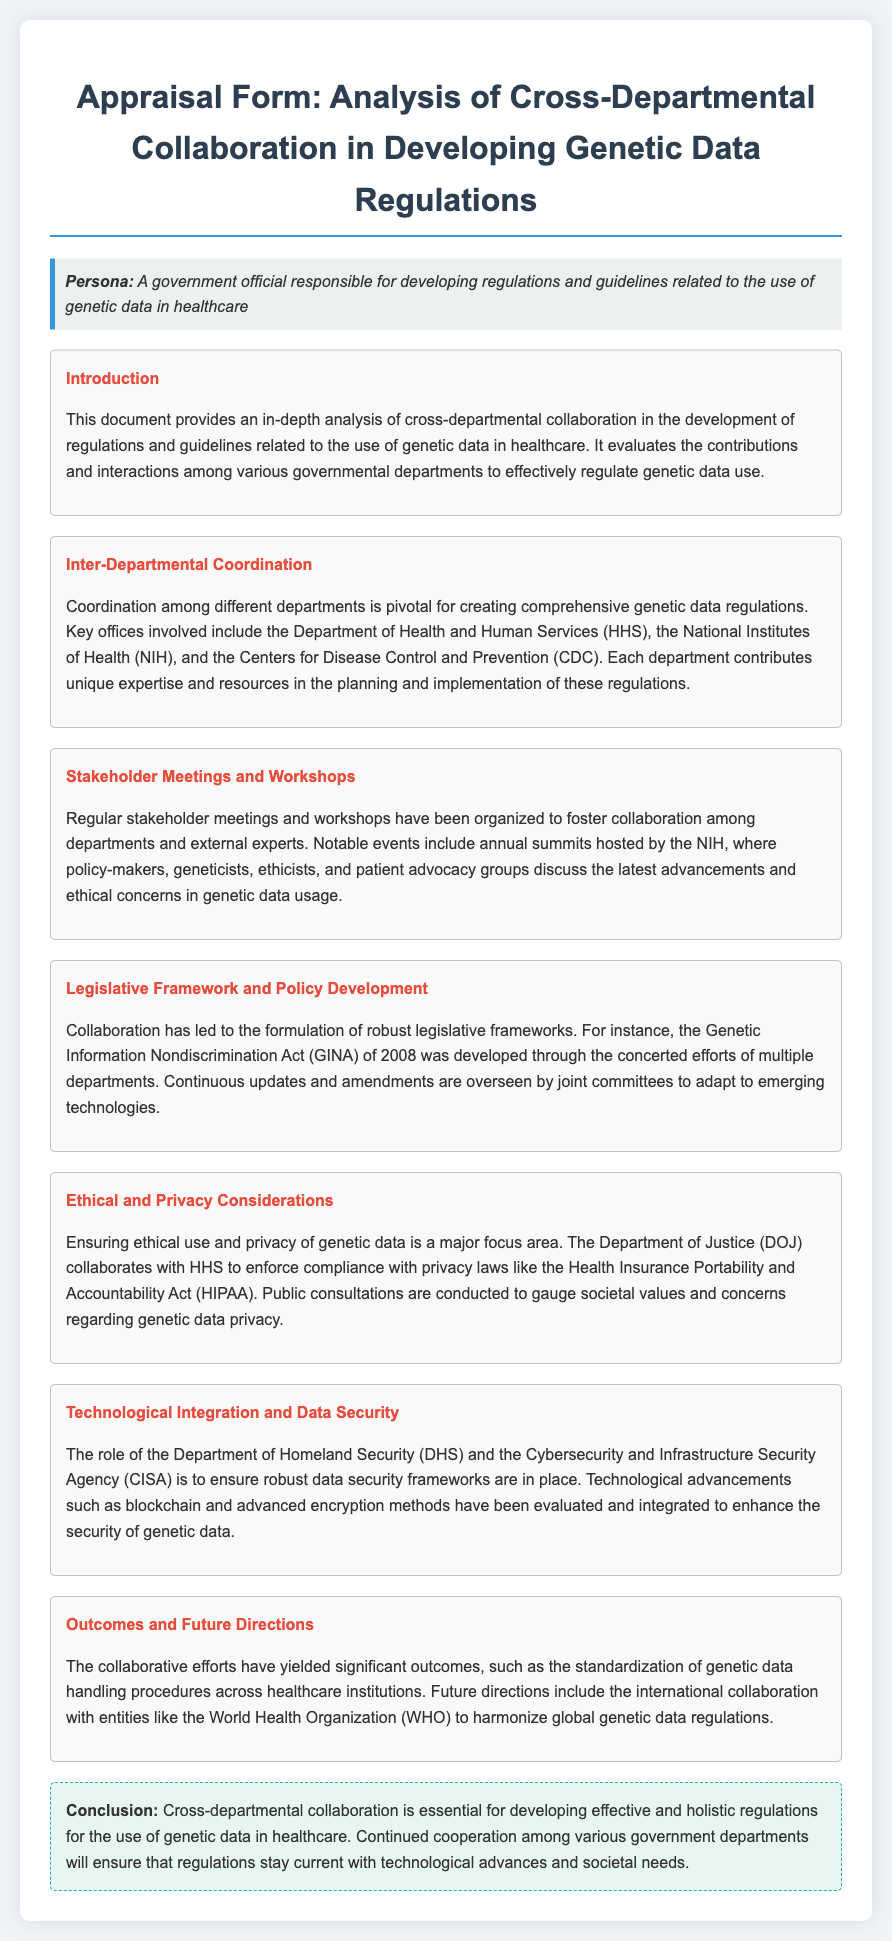what is the title of this document? The title is provided at the beginning of the document, which describes the appraisal form's focus.
Answer: Appraisal Form: Analysis of Cross-Departmental Collaboration in Developing Genetic Data Regulations which departments are mentioned as key contributors? The document explicitly lists several departments that play a crucial role in developing regulations for genetic data.
Answer: HHS, NIH, CDC what significant act was developed through cross-departmental collaboration? The act mentioned in the document is highlighted in the section on legislative frameworks and policy development.
Answer: Genetic Information Nondiscrimination Act (GINA) what is a major focus area regarding genetic data? This focus area is discussed within the context of ethical and privacy considerations in the document.
Answer: Ethical use and privacy which department collaborates with HHS on privacy compliance? The document specifies a department that works alongside HHS to enforce compliance with privacy laws.
Answer: Department of Justice (DOJ) how many outcomes are mentioned in the collaborative efforts? The document states the outcomes of collaboration but does not list them numerically, focusing instead on the significance of collaboration.
Answer: Significant outcomes what future collaboration entity is mentioned in the document? The future direction of collaboration involves an international entity stated at the end of the document.
Answer: World Health Organization (WHO) what kind of meetings are organized to foster collaboration? The document describes specific types of gatherings aimed at improving inter-departmental cooperation.
Answer: Stakeholder meetings and workshops 